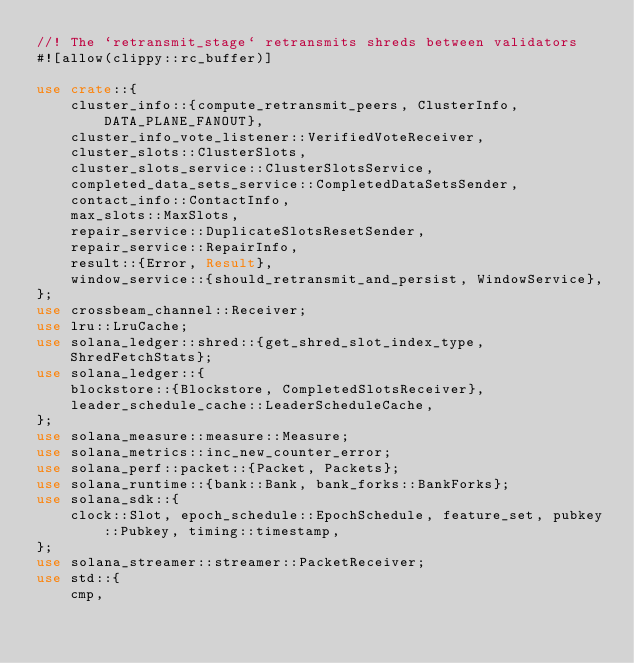<code> <loc_0><loc_0><loc_500><loc_500><_Rust_>//! The `retransmit_stage` retransmits shreds between validators
#![allow(clippy::rc_buffer)]

use crate::{
    cluster_info::{compute_retransmit_peers, ClusterInfo, DATA_PLANE_FANOUT},
    cluster_info_vote_listener::VerifiedVoteReceiver,
    cluster_slots::ClusterSlots,
    cluster_slots_service::ClusterSlotsService,
    completed_data_sets_service::CompletedDataSetsSender,
    contact_info::ContactInfo,
    max_slots::MaxSlots,
    repair_service::DuplicateSlotsResetSender,
    repair_service::RepairInfo,
    result::{Error, Result},
    window_service::{should_retransmit_and_persist, WindowService},
};
use crossbeam_channel::Receiver;
use lru::LruCache;
use solana_ledger::shred::{get_shred_slot_index_type, ShredFetchStats};
use solana_ledger::{
    blockstore::{Blockstore, CompletedSlotsReceiver},
    leader_schedule_cache::LeaderScheduleCache,
};
use solana_measure::measure::Measure;
use solana_metrics::inc_new_counter_error;
use solana_perf::packet::{Packet, Packets};
use solana_runtime::{bank::Bank, bank_forks::BankForks};
use solana_sdk::{
    clock::Slot, epoch_schedule::EpochSchedule, feature_set, pubkey::Pubkey, timing::timestamp,
};
use solana_streamer::streamer::PacketReceiver;
use std::{
    cmp,</code> 